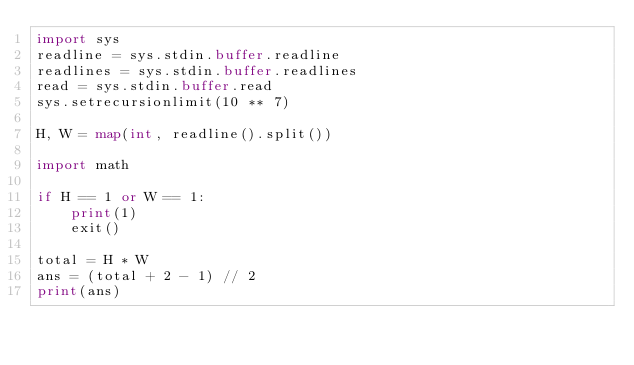<code> <loc_0><loc_0><loc_500><loc_500><_Python_>import sys
readline = sys.stdin.buffer.readline
readlines = sys.stdin.buffer.readlines
read = sys.stdin.buffer.read
sys.setrecursionlimit(10 ** 7)

H, W = map(int, readline().split())

import math

if H == 1 or W == 1:
    print(1)
    exit()

total = H * W
ans = (total + 2 - 1) // 2
print(ans)</code> 